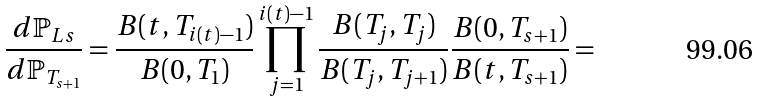<formula> <loc_0><loc_0><loc_500><loc_500>\frac { d \mathbb { P } _ { L s } } { d \mathbb { P } _ { T _ { s + 1 } } } = \frac { B ( t , T _ { i ( t ) - 1 } ) } { B ( 0 , T _ { 1 } ) } \prod _ { j = 1 } ^ { i ( t ) - 1 } \frac { B ( T _ { j } , T _ { j } ) } { B ( T _ { j } , T _ { j + 1 } ) } \frac { B ( 0 , T _ { s + 1 } ) } { B ( t , T _ { s + 1 } ) } =</formula> 